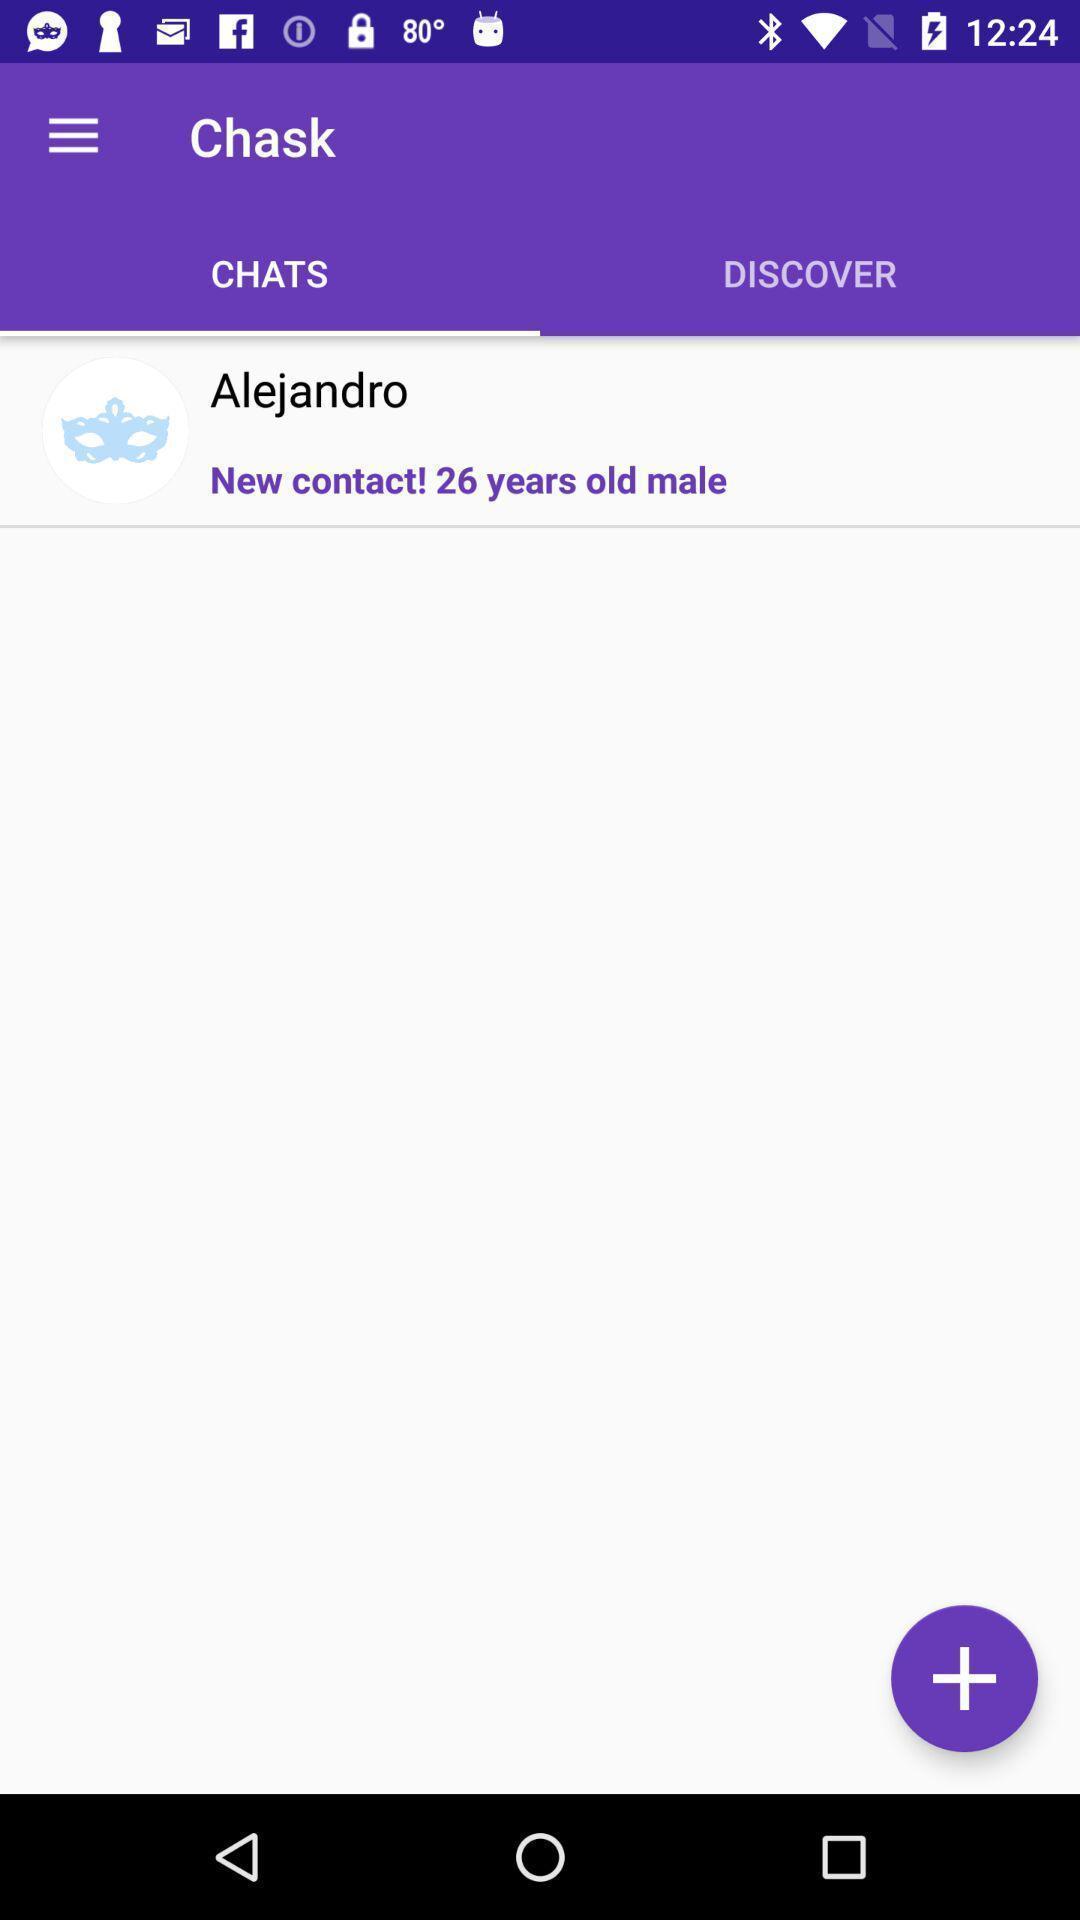Describe the key features of this screenshot. Single contact is displaying under chats. 